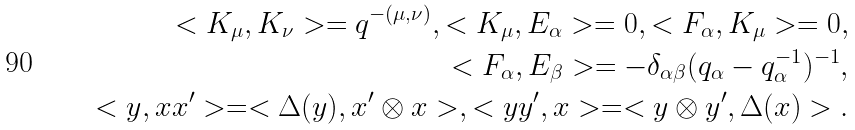<formula> <loc_0><loc_0><loc_500><loc_500>< K _ { \mu } , K _ { \nu } > = q ^ { - ( \mu , \nu ) } , < K _ { \mu } , E _ { \alpha } > = 0 , < F _ { \alpha } , K _ { \mu } > = 0 , \\ < F _ { \alpha } , E _ { \beta } > = - \delta _ { \alpha \beta } ( q _ { \alpha } - q _ { \alpha } ^ { - 1 } ) ^ { - 1 } , \\ < y , x x ^ { \prime } > = < \Delta ( y ) , x ^ { \prime } \otimes x > , < y y ^ { \prime } , x > = < y \otimes y ^ { \prime } , \Delta ( x ) > .</formula> 